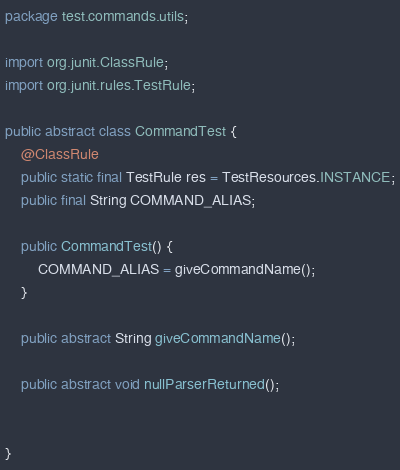<code> <loc_0><loc_0><loc_500><loc_500><_Java_>package test.commands.utils;

import org.junit.ClassRule;
import org.junit.rules.TestRule;

public abstract class CommandTest {
	@ClassRule
	public static final TestRule res = TestResources.INSTANCE;
	public final String COMMAND_ALIAS;

	public CommandTest() {
		COMMAND_ALIAS = giveCommandName();
	}

	public abstract String giveCommandName();

	public abstract void nullParserReturned();


}
</code> 